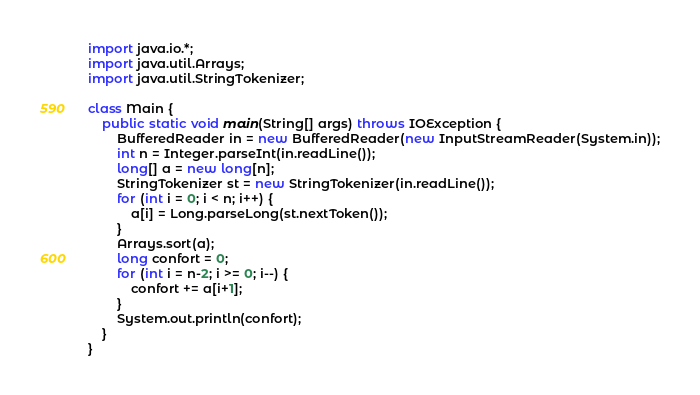Convert code to text. <code><loc_0><loc_0><loc_500><loc_500><_Java_>import java.io.*;
import java.util.Arrays;
import java.util.StringTokenizer;

class Main {
    public static void main(String[] args) throws IOException {
        BufferedReader in = new BufferedReader(new InputStreamReader(System.in));
        int n = Integer.parseInt(in.readLine());
        long[] a = new long[n];
        StringTokenizer st = new StringTokenizer(in.readLine());
        for (int i = 0; i < n; i++) {
            a[i] = Long.parseLong(st.nextToken());
        }
        Arrays.sort(a);
        long confort = 0;
        for (int i = n-2; i >= 0; i--) {
            confort += a[i+1];
        }
        System.out.println(confort);
    }
}
</code> 